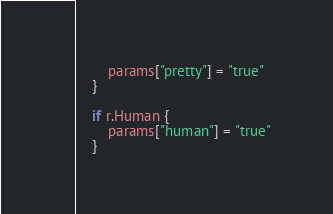<code> <loc_0><loc_0><loc_500><loc_500><_Go_>		params["pretty"] = "true"
	}

	if r.Human {
		params["human"] = "true"
	}
</code> 